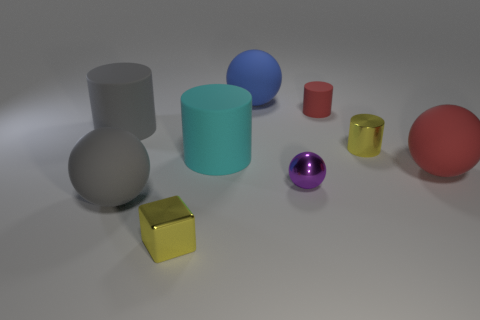There is a yellow metal thing that is right of the tiny shiny cube; what shape is it?
Offer a terse response. Cylinder. Is the small yellow cylinder made of the same material as the large gray sphere?
Provide a succinct answer. No. Are there any other things that have the same material as the tiny purple thing?
Provide a succinct answer. Yes. What material is the red object that is the same shape as the purple object?
Your answer should be compact. Rubber. Are there fewer small yellow shiny objects that are left of the purple shiny ball than red things?
Your response must be concise. Yes. There is a tiny cube; how many big gray matte cylinders are to the right of it?
Offer a very short reply. 0. Do the yellow metallic object that is behind the yellow cube and the big rubber thing behind the large gray matte cylinder have the same shape?
Your response must be concise. No. What shape is the thing that is both behind the cyan rubber cylinder and right of the small red object?
Provide a succinct answer. Cylinder. There is a red ball that is the same material as the gray cylinder; what size is it?
Your answer should be very brief. Large. Is the number of large red balls less than the number of small red shiny cubes?
Offer a very short reply. No. 